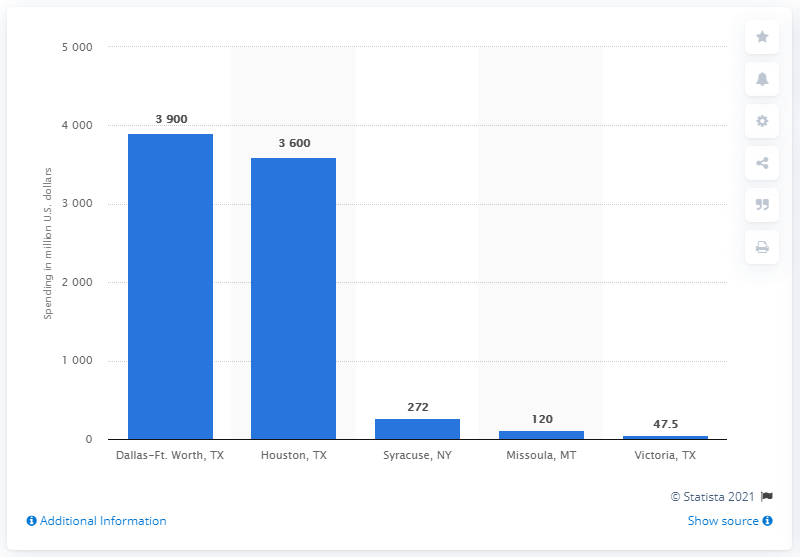Outline some significant characteristics in this image. According to estimates, the amount of ad revenue in Syracuse, New York in 2017 was approximately $272. 